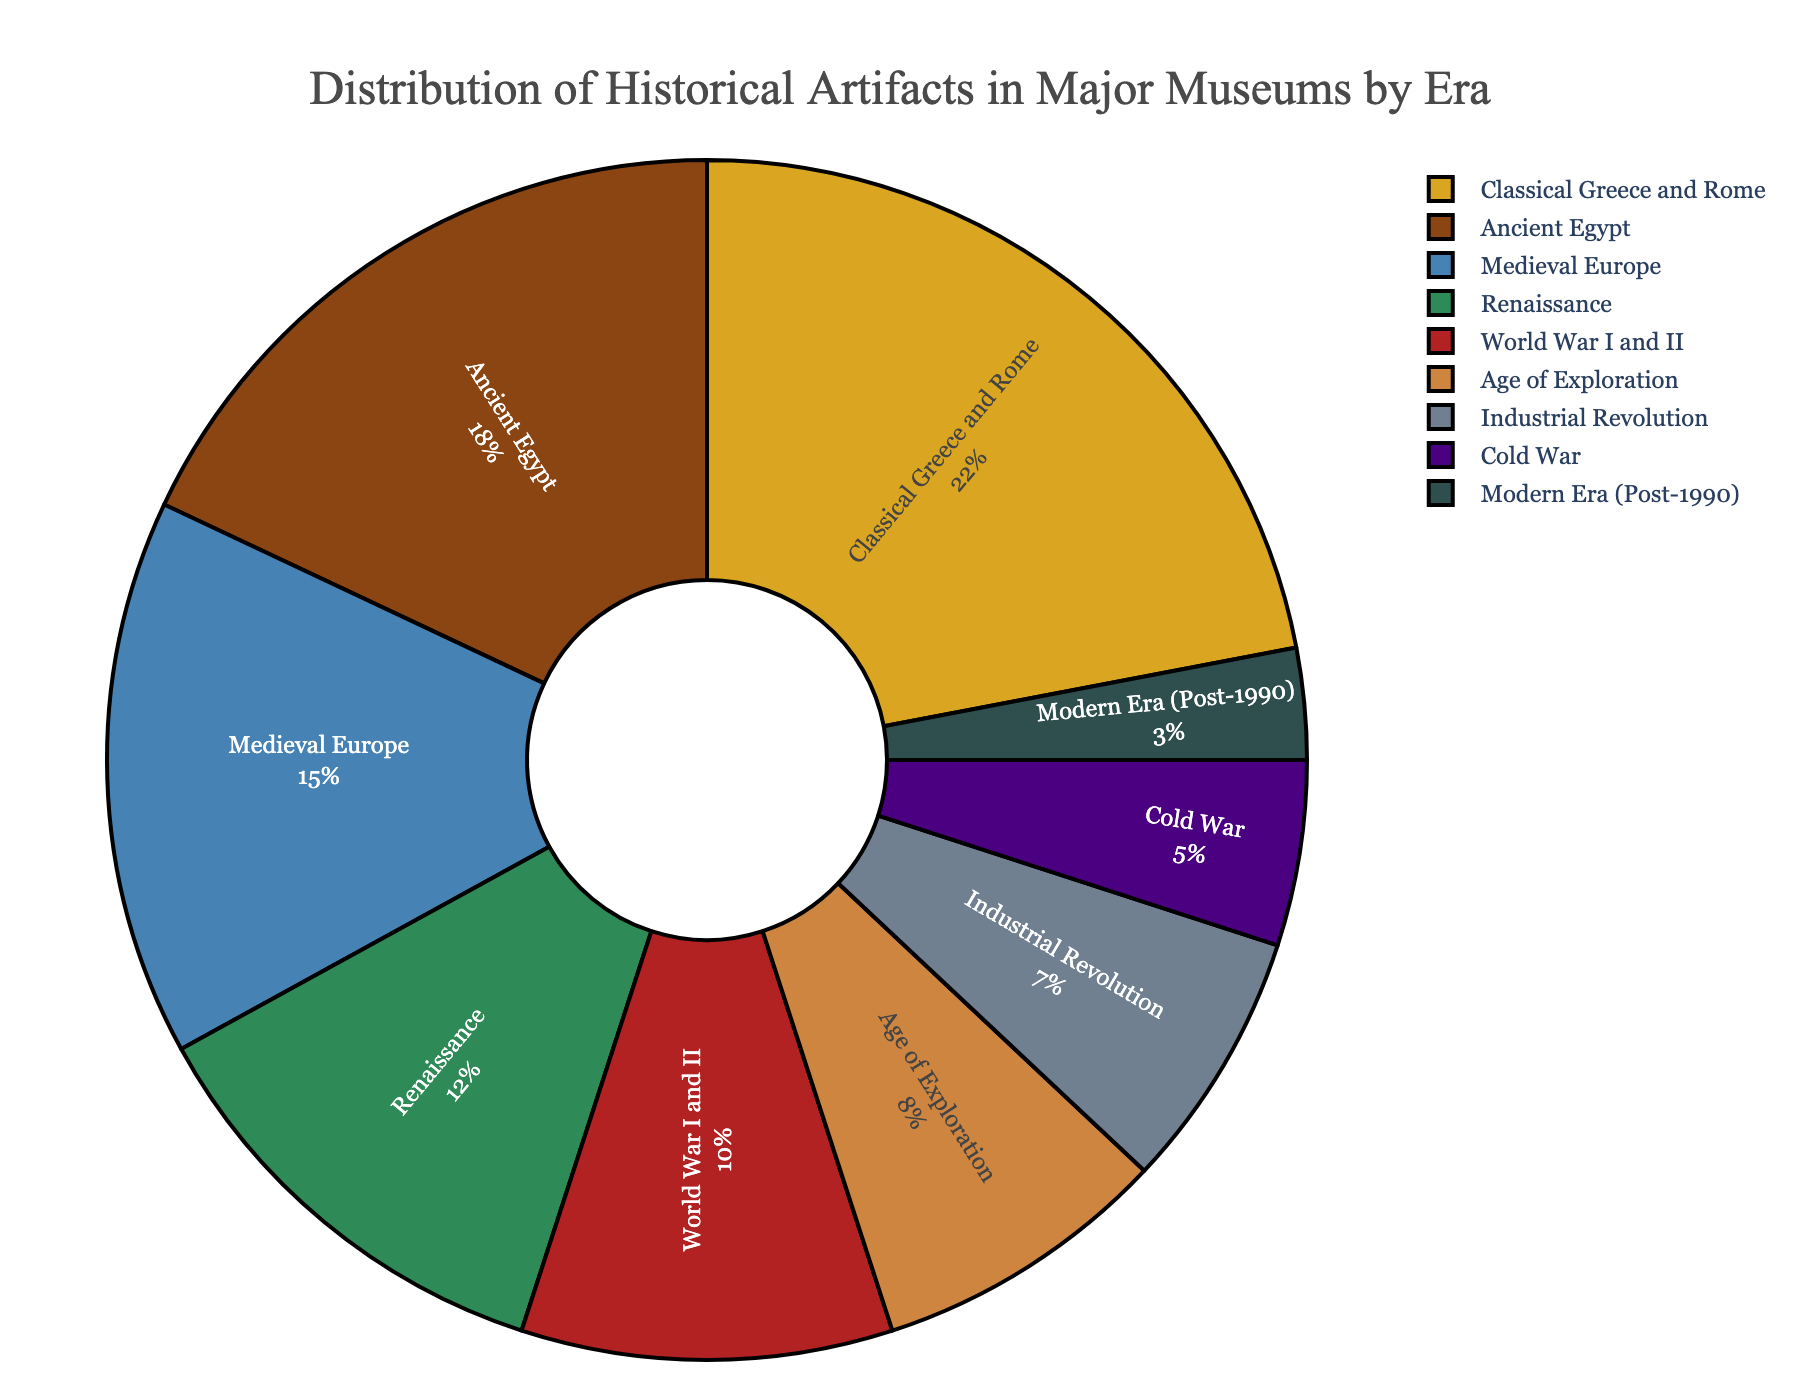Which era has the highest percentage of historical artifacts in major museums? By observing the pie chart, the Classical Greece and Rome section is the largest.
Answer: Classical Greece and Rome What is the combined percentage of artifacts from the Classical Greece and Rome era and the Medieval Europe era? The pie chart shows 22% for Classical Greece and Rome and 15% for Medieval Europe. Adding these percentages together gives 22 + 15 = 37.
Answer: 37% Which era has a greater percentage of artifacts, the Renaissance or the Industrial Revolution? The pie chart indicates that the Renaissance era has 12% while the Industrial Revolution has 7%. 12% is greater than 7%.
Answer: Renaissance How many eras have a percentage of artifacts that is below 10%? Observing the pie chart and listing the percentages less than 10%, we see that Age of Exploration (8%), Industrial Revolution (7%), Cold War (5%), and Modern Era (3%) are all below 10%. This gives us 4 eras.
Answer: 4 What is the difference in percentage between the Ancient Egypt and Modern Era artifacts? The pie chart shows 18% for Ancient Egypt and 3% for Modern Era. The difference is found by subtracting 3 from 18, which gives 18 - 3 = 15.
Answer: 15% What is the percentage of World War I and II artifacts compared to the total percentage of Age of Exploration and Cold War artifacts? World War I and II is at 10%. Age of Exploration and Cold War are 8% and 5%, respectively. The combined percentage for Age of Exploration and Cold War is 8 + 5 = 13. Comparing 10% with 13%, World War I and II artifacts are smaller.
Answer: Smaller Which colors are associated with the Industrial Revolution and the Cold War in the pie chart? The color for Industrial Revolution is likely a grey or muted tone, while the Cold War is associated with a dark shade. Specifically, the Industrial Revolution might be a slate grey, and the Cold War an indigo or near-black tone.
Answer: Slate grey and indigo Is the percentage of artifacts from the Modern Era more or less than a third of the percentage of artifacts from the Ancient Egypt Era? The Modern Era is 3% and Ancient Egypt is 18%. A third of 18 is 18/3 = 6. Since 3% is less than 6%, the Modern Era has less than a third of the percentage of Ancient Egypt.
Answer: Less What is the total percentage of artifacts from eras before the Industrial Revolution? Adding the percentages from Ancient Egypt (18%), Classical Greece and Rome (22%), Medieval Europe (15%), Renaissance (12%), and Age of Exploration (8%), we get 18 + 22 + 15 + 12 + 8 = 75.
Answer: 75% Which era has the smallest representation of artifacts in major museums? The pie chart indicates the smallest section is the Modern Era (Post-1990) at 3%.
Answer: Modern Era (Post-1990) 